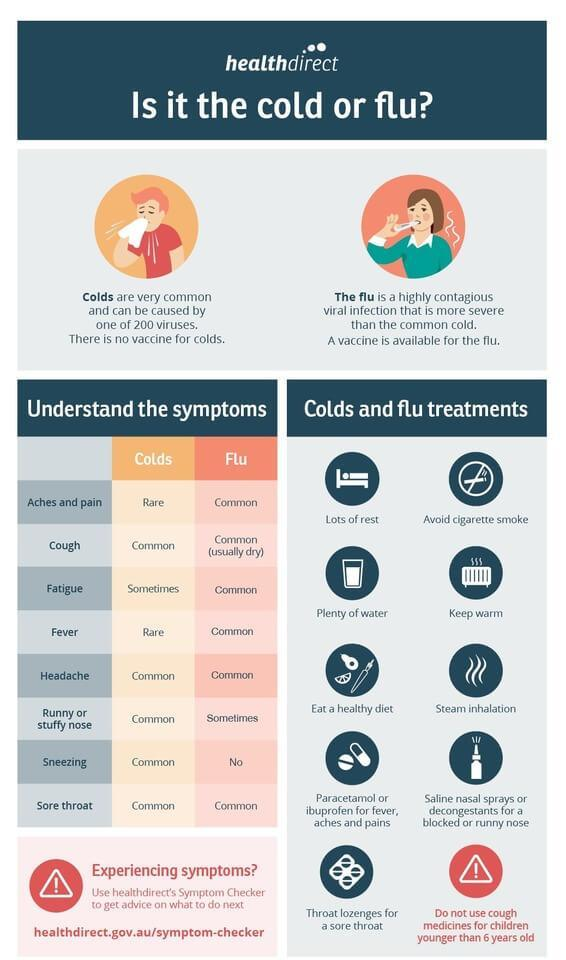Which symptoms are common for both cold & flu?
Answer the question with a short phrase. Cough, Headache, Sore throat Which symptom do occur sometimes in the cold? Fatigue Which symptom do occur sometimes in the Flu? Runny or stuffy nose Which symptoms are rare for cold? Aches and pain, Fever Which is never a symptom of flu? Sneezing 